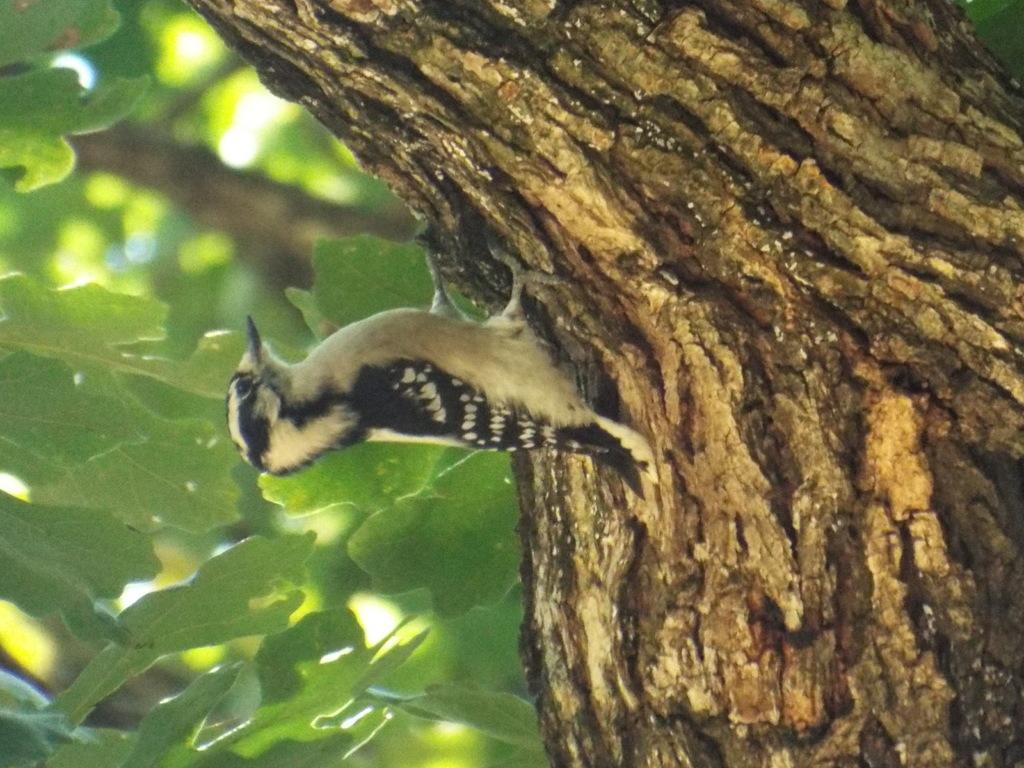What type of animal is in the image? There is a bird in the image. Where is the bird located? The bird is standing on a tree trunk. What can be seen in the background of the image? There are leaves visible in the background of the image. What type of chair is the bird sitting on in the image? There is no chair present in the image; the bird is standing on a tree trunk. What country is the bird from in the image? The image does not provide information about the bird's origin or country. 